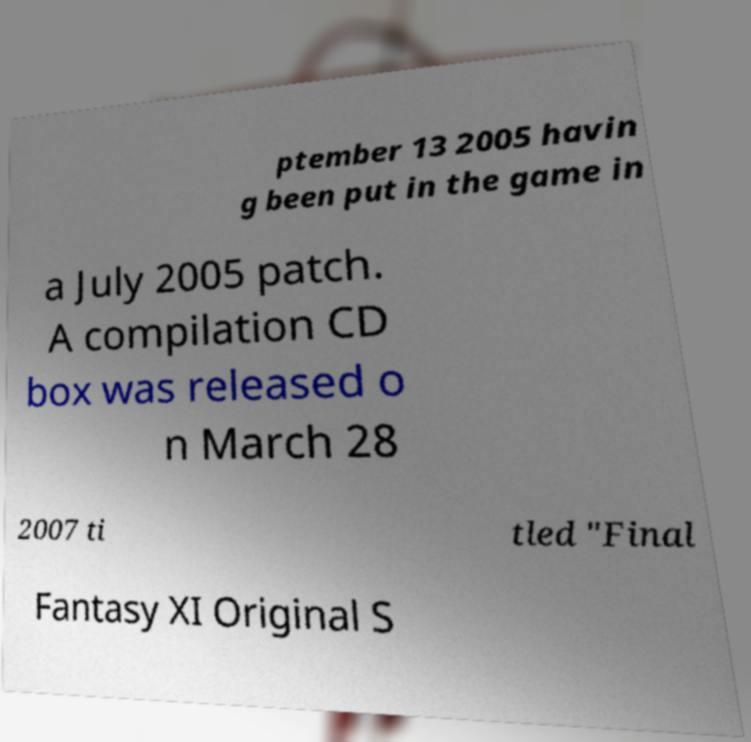For documentation purposes, I need the text within this image transcribed. Could you provide that? ptember 13 2005 havin g been put in the game in a July 2005 patch. A compilation CD box was released o n March 28 2007 ti tled "Final Fantasy XI Original S 